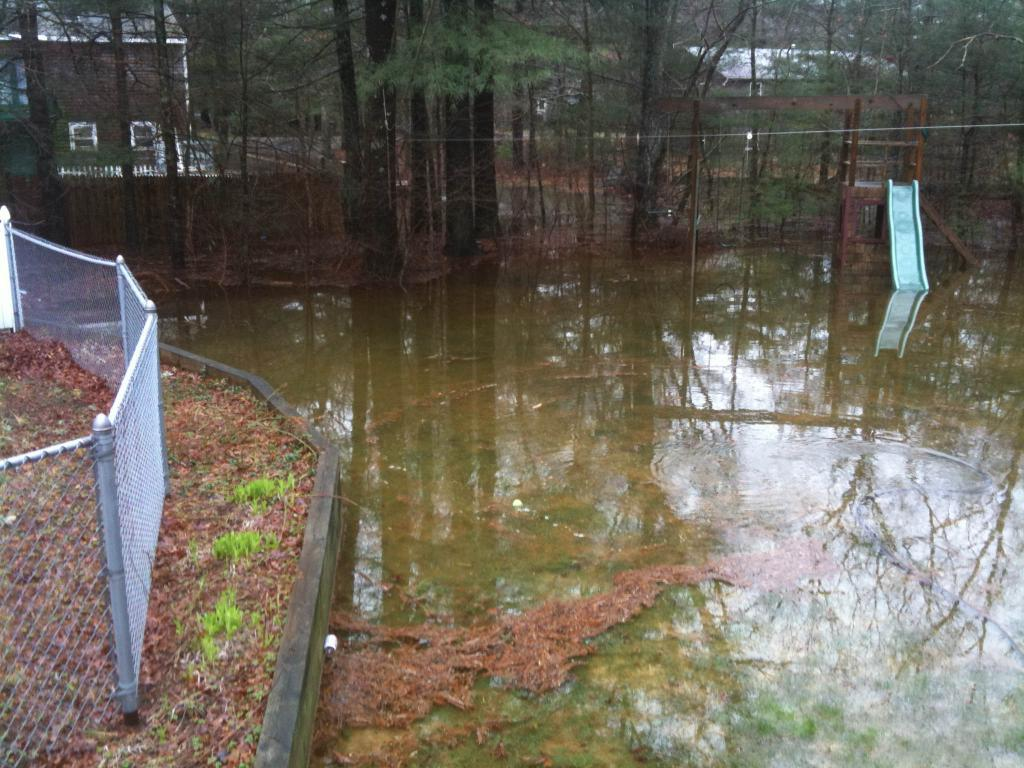What is the primary element in the image? There is water in the image. What feature is present within the water? There is a slide in the water. What can be seen on the left side of the image? There is fencing on the left side of the image. What is visible in the background of the image? There are houses and trees in the background of the image. What type of curtain can be seen hanging from the slide in the image? There is no curtain present in the image, and the slide does not have any hanging from it. 